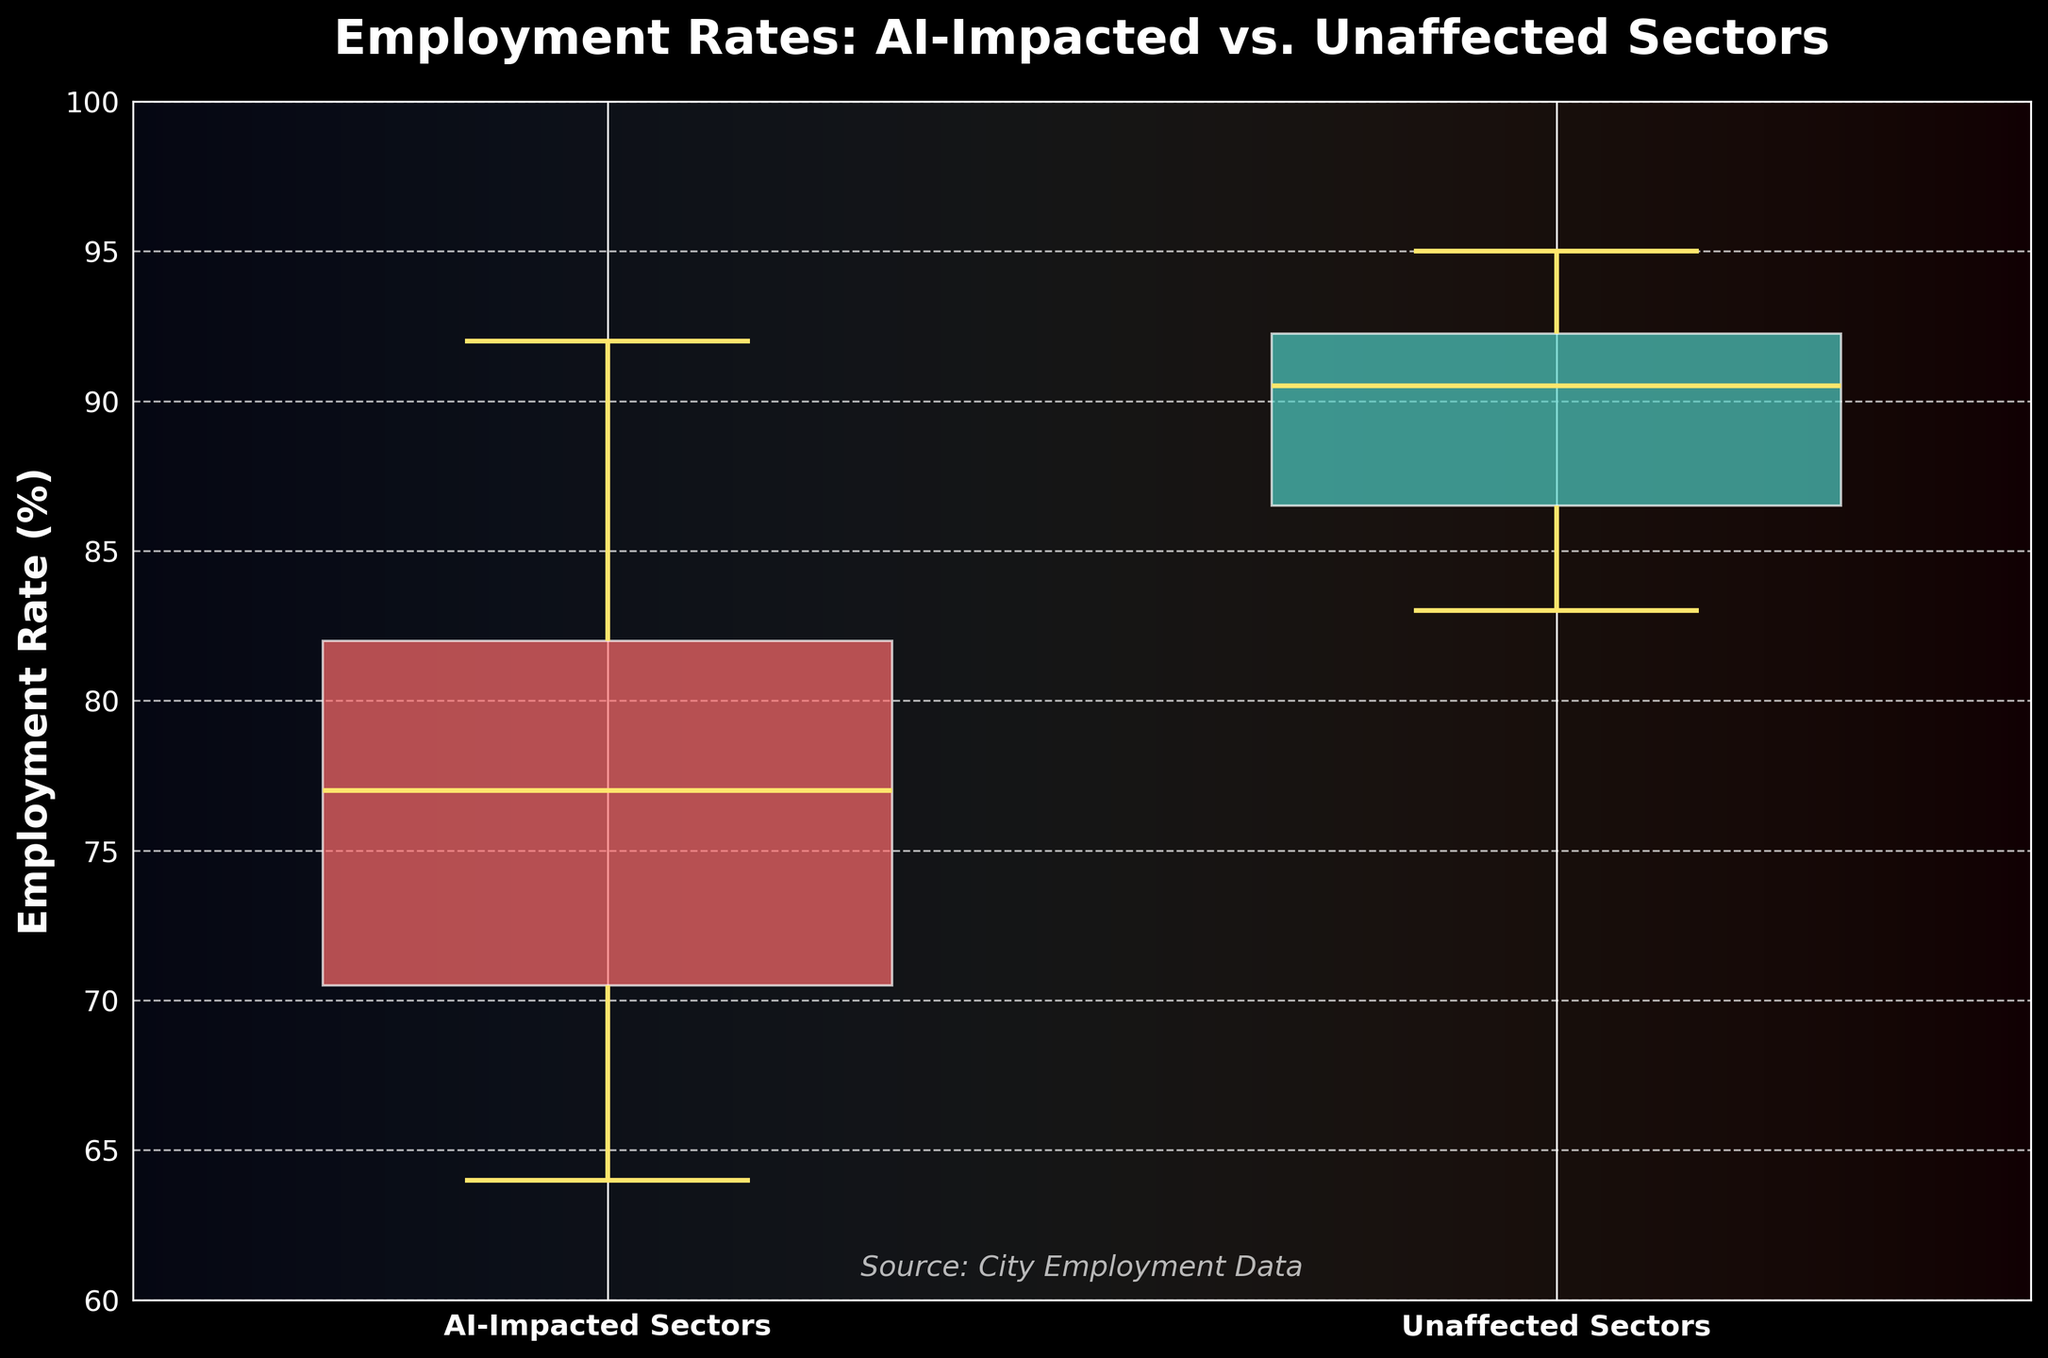What is the title of the figure? The title is typically the text displayed at the top of the figure. In this case, it's "Employment Rates: AI-Impacted vs. Unaffected Sectors".
Answer: Employment Rates: AI-Impacted vs. Unaffected Sectors Which group has a higher median employment rate? To find the median employment rate, locate the middle line inside each box plot. The box plot for the unaffected sectors has a higher median line compared to the AI-impacted sectors.
Answer: Unaffected sectors What colors are used to represent the AI-Impacted and Unaffected sectors? The colors of the box plots represent different groups. For AI-Impacted sectors, it's a reddish color, and for Unaffected sectors, it's a greenish color.
Answer: Reddish for AI-Impacted, greenish for Unaffected What is the approximate upper whisker value for the AI-Impacted sectors? The upper whisker of the box plot extends from the top of the box to the largest value within 1.5 times the interquartile range. For AI-Impacted sectors, this is around 92-93.
Answer: Around 92-93 How much higher is the median employment rate of unaffected sectors compared to AI-impacted sectors? The median value for unaffected sectors is around 90, and for AI-impacted sectors, it's around 78. The difference is 90 - 78 = 12.
Answer: 12 Which group has a wider interquartile range? The interquartile range (IQR) is the difference between the upper and lower quartiles (middle 50% of data). The AI-impacted sectors have a wider IQR compared to unaffected sectors, as seen by the larger height of the box.
Answer: AI-impacted sectors What is the approximate lower whisker value for the Unaffected sectors? The lower whisker of the box plot extends from the bottom of the box to the smallest value within 1.5 times the interquartile range. For Unaffected sectors, this is around 83-84.
Answer: Around 83-84 Which sector category shows more variability in employment rate? Variability in a box plot can be assessed by the range and IQR. The AI-impacted sectors show more variability indicated by a larger box and wider whiskers.
Answer: AI-impacted sectors By how much does the maximum employment rate for AI-Impacted sectors exceed the minimum employment rate for the same group? The maximum employment rate for AI-Impacted sectors is around 92-93 and the minimum is around 64. The difference is 92-64.
Answer: 28 